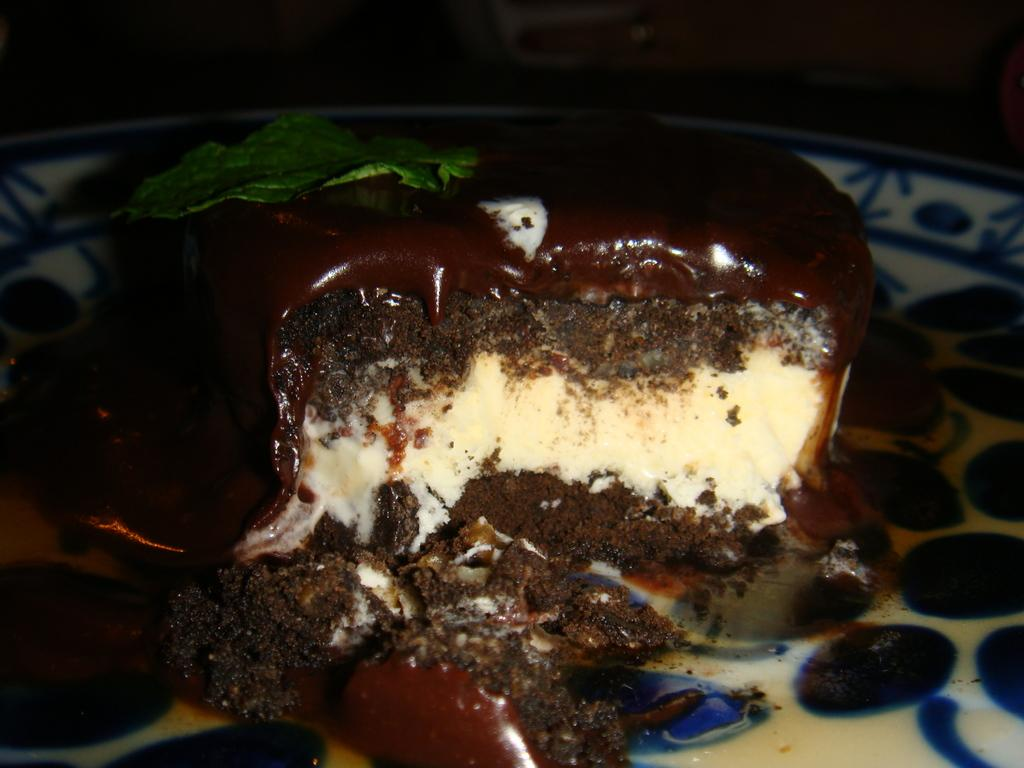What is the main subject of the image? The main subject of the image is a cake. How is the cake presented in the image? The cake is on a plate in the image. Are there any decorations or additional elements on the cake? Yes, there is a leaf on the cake. What type of pain can be seen on the faces of the people in the image? There are no people present in the image, only a cake with a leaf on it. 